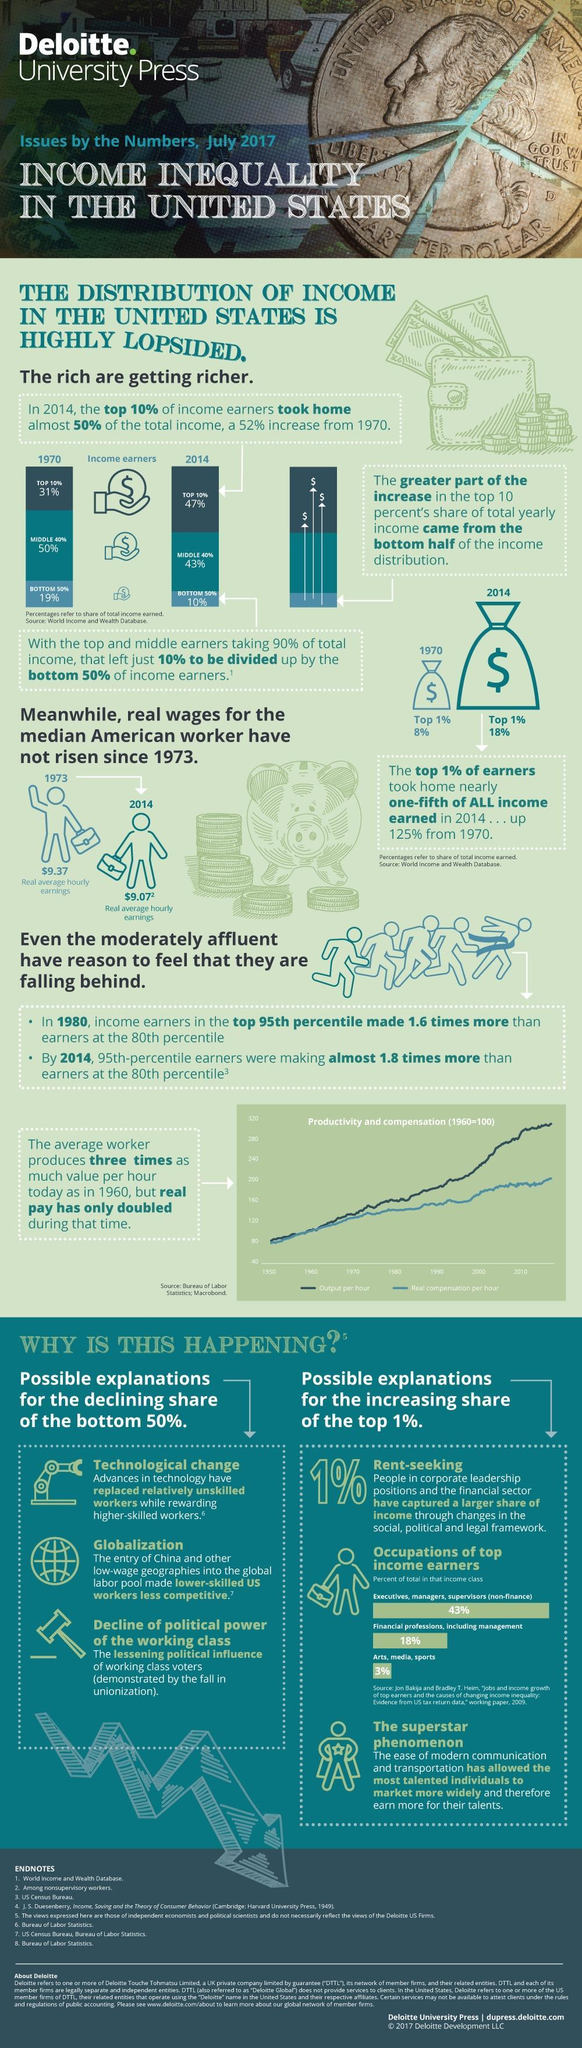since when has the real wages been same?
Answer the question with a short phrase. 1973 what is the percent of total for the top two income class 61 what has made US workers less competitive the entry of china and other low-wage geographies into the global labor pool what has the increase been from 1970 to 2014 52% which category so the 3% of top income earners belong to arts, media, sports in 2014 what was the share of the top 1% 18% in 1970 what was the the share of the top 1% 8% 